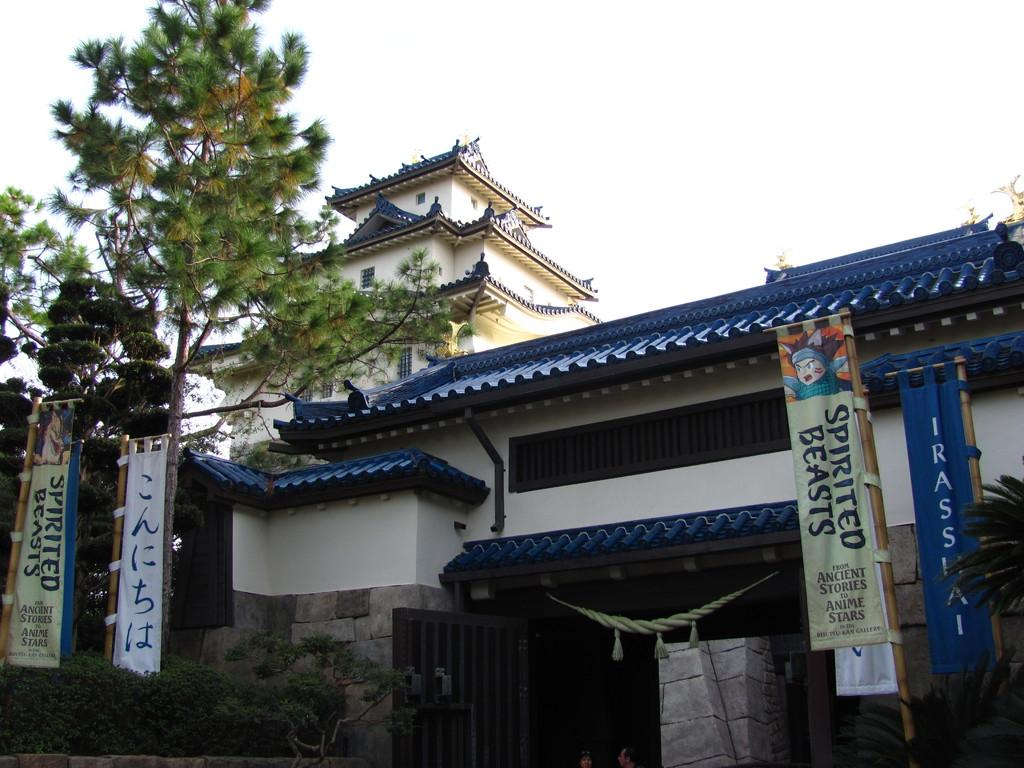What type of vegetation can be seen in the image? There are small plants and shrubs in the image. What type of structure is present in the image? There is a stone wall in the image. What are the banners attached to in the image? The banners are attached to wooden sticks in the image. What type of entrance is visible in the image? There is a gate in the image. What architectural style is featured in the image? The image features Chinese architecture. What can be seen in the background of the image? There are trees and the sky visible in the background of the image. What type of test is being conducted in the image? There is no test being conducted in the image; it features plants, shrubs, a stone wall, banners, a gate, and Chinese architecture. What type of support is visible in the image? There is no specific support structure visible in the image; it features a stone wall and wooden sticks for banners. 